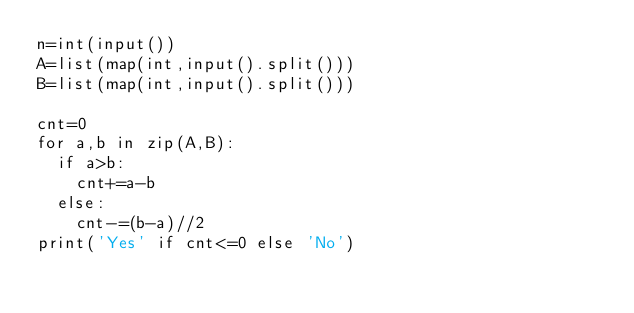Convert code to text. <code><loc_0><loc_0><loc_500><loc_500><_Python_>n=int(input())
A=list(map(int,input().split()))
B=list(map(int,input().split()))

cnt=0
for a,b in zip(A,B):
  if a>b:
    cnt+=a-b
  else:
    cnt-=(b-a)//2
print('Yes' if cnt<=0 else 'No')</code> 